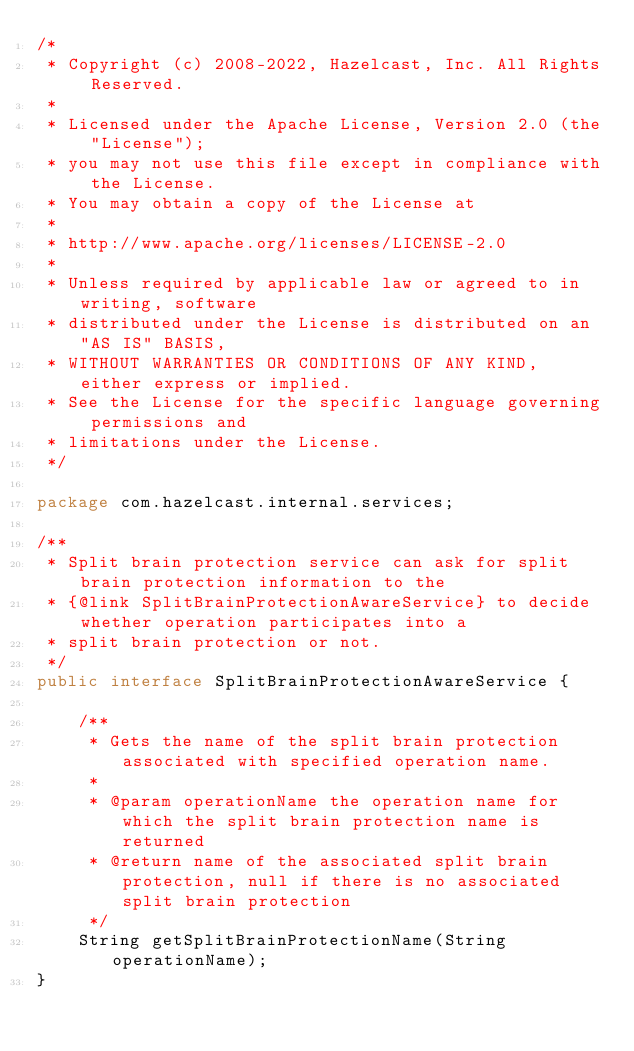<code> <loc_0><loc_0><loc_500><loc_500><_Java_>/*
 * Copyright (c) 2008-2022, Hazelcast, Inc. All Rights Reserved.
 *
 * Licensed under the Apache License, Version 2.0 (the "License");
 * you may not use this file except in compliance with the License.
 * You may obtain a copy of the License at
 *
 * http://www.apache.org/licenses/LICENSE-2.0
 *
 * Unless required by applicable law or agreed to in writing, software
 * distributed under the License is distributed on an "AS IS" BASIS,
 * WITHOUT WARRANTIES OR CONDITIONS OF ANY KIND, either express or implied.
 * See the License for the specific language governing permissions and
 * limitations under the License.
 */

package com.hazelcast.internal.services;

/**
 * Split brain protection service can ask for split brain protection information to the
 * {@link SplitBrainProtectionAwareService} to decide whether operation participates into a
 * split brain protection or not.
 */
public interface SplitBrainProtectionAwareService {

    /**
     * Gets the name of the split brain protection associated with specified operation name.
     *
     * @param operationName the operation name for which the split brain protection name is returned
     * @return name of the associated split brain protection, null if there is no associated split brain protection
     */
    String getSplitBrainProtectionName(String operationName);
}
</code> 